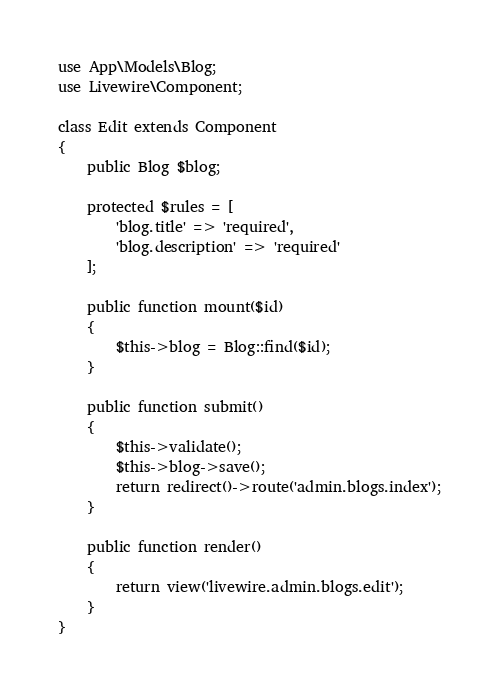<code> <loc_0><loc_0><loc_500><loc_500><_PHP_>use App\Models\Blog;
use Livewire\Component;

class Edit extends Component
{
    public Blog $blog;

    protected $rules = [
        'blog.title' => 'required',
        'blog.description' => 'required'
    ];

    public function mount($id)
    {
        $this->blog = Blog::find($id);
    }

    public function submit()
    {
        $this->validate();
        $this->blog->save();
        return redirect()->route('admin.blogs.index');
    }

    public function render()
    {
        return view('livewire.admin.blogs.edit');
    }
}
</code> 